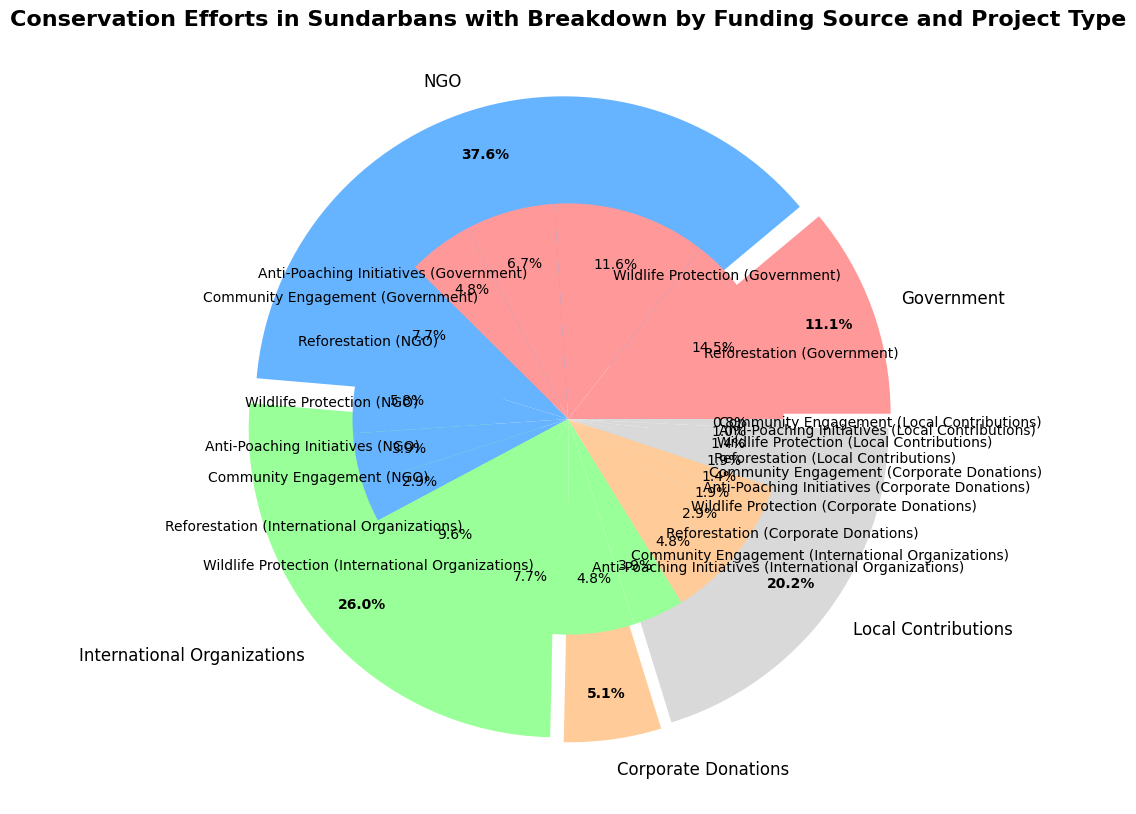Which funding source contributes the most to conservation efforts in the Sundarbans? Look at the outer pie chart and identify the largest section. The largest section represents the contribution by the Government.
Answer: Government What percentage of the total funding is contributed by the Government? The outer pie chart shows that the Government's contribution is 42.5% of the total funding.
Answer: 42.5% Which project type receives the least funding from Corporate Donations? In the inner pie chart, the smallest segment within Corporate Donations is for Community Engagement. This segment is labeled with the amount and percentage for verification.
Answer: Community Engagement How does the total funding from International Organizations for Wildlife Protection compare to the total funding from NGOs for Community Engagement? The inner pie chart shows that International Organizations contribute $80,000 to Wildlife Protection, whereas NGOs contribute $30,000 to Community Engagement. Thus, International Organizations give more to Wildlife Protection compared to NGOs for Community Engagement.
Answer: International Organizations contribute more Within Reforestation projects, which funding source provides the least amount of money? The inner pie chart shows that Local Contributions provide $20,000 for Reforestation, which is the smallest amount among the funding sources for this project type.
Answer: Local Contributions What is the total amount contributed by NGOs across all project types? Add the amounts of each project type funded by NGOs: $80,000 (Reforestation) + $60,000 (Wildlife Protection) + $40,000 (Anti-Poaching Initiatives) + $30,000 (Community Engagement) = $210,000.
Answer: $210,000 What percentage of Reforestation funding comes from Corporate Donations compared to the overall Reforestation funding? The inner pie chart shows Corporate Donations contribute $50,000 to Reforestation. The total for Reforestation can be calculated by adding the amounts from all funding sources: $150,000 (Government) + $80,000 (NGO) + $100,000 (International Organizations) + $50,000 (Corporate Donations) + $20,000 (Local Contributions) = $400,000. Thus, the percentage is ($50,000 / $400,000) * 100% = 12.5%.
Answer: 12.5% How does the funding for Anti-Poaching Initiatives from Government compare to Corporate Donations? The inner pie chart shows the Government allocates $70,000 to Anti-Poaching Initiatives, whereas Corporate Donations provide $20,000 to the same initiative. Hence, the Government funds substantially more than Corporate Donations for Anti-Poaching Initiatives.
Answer: Government funds more Which project type receives equal or close funding amounts from NGOs and Local Contributions? In the inner pie chart, Community Engagement receives $30,000 from NGOs and $8,000 from Local Contributions. While not equal, these amounts are relatively closer compared to other project types.
Answer: Community Engagement 